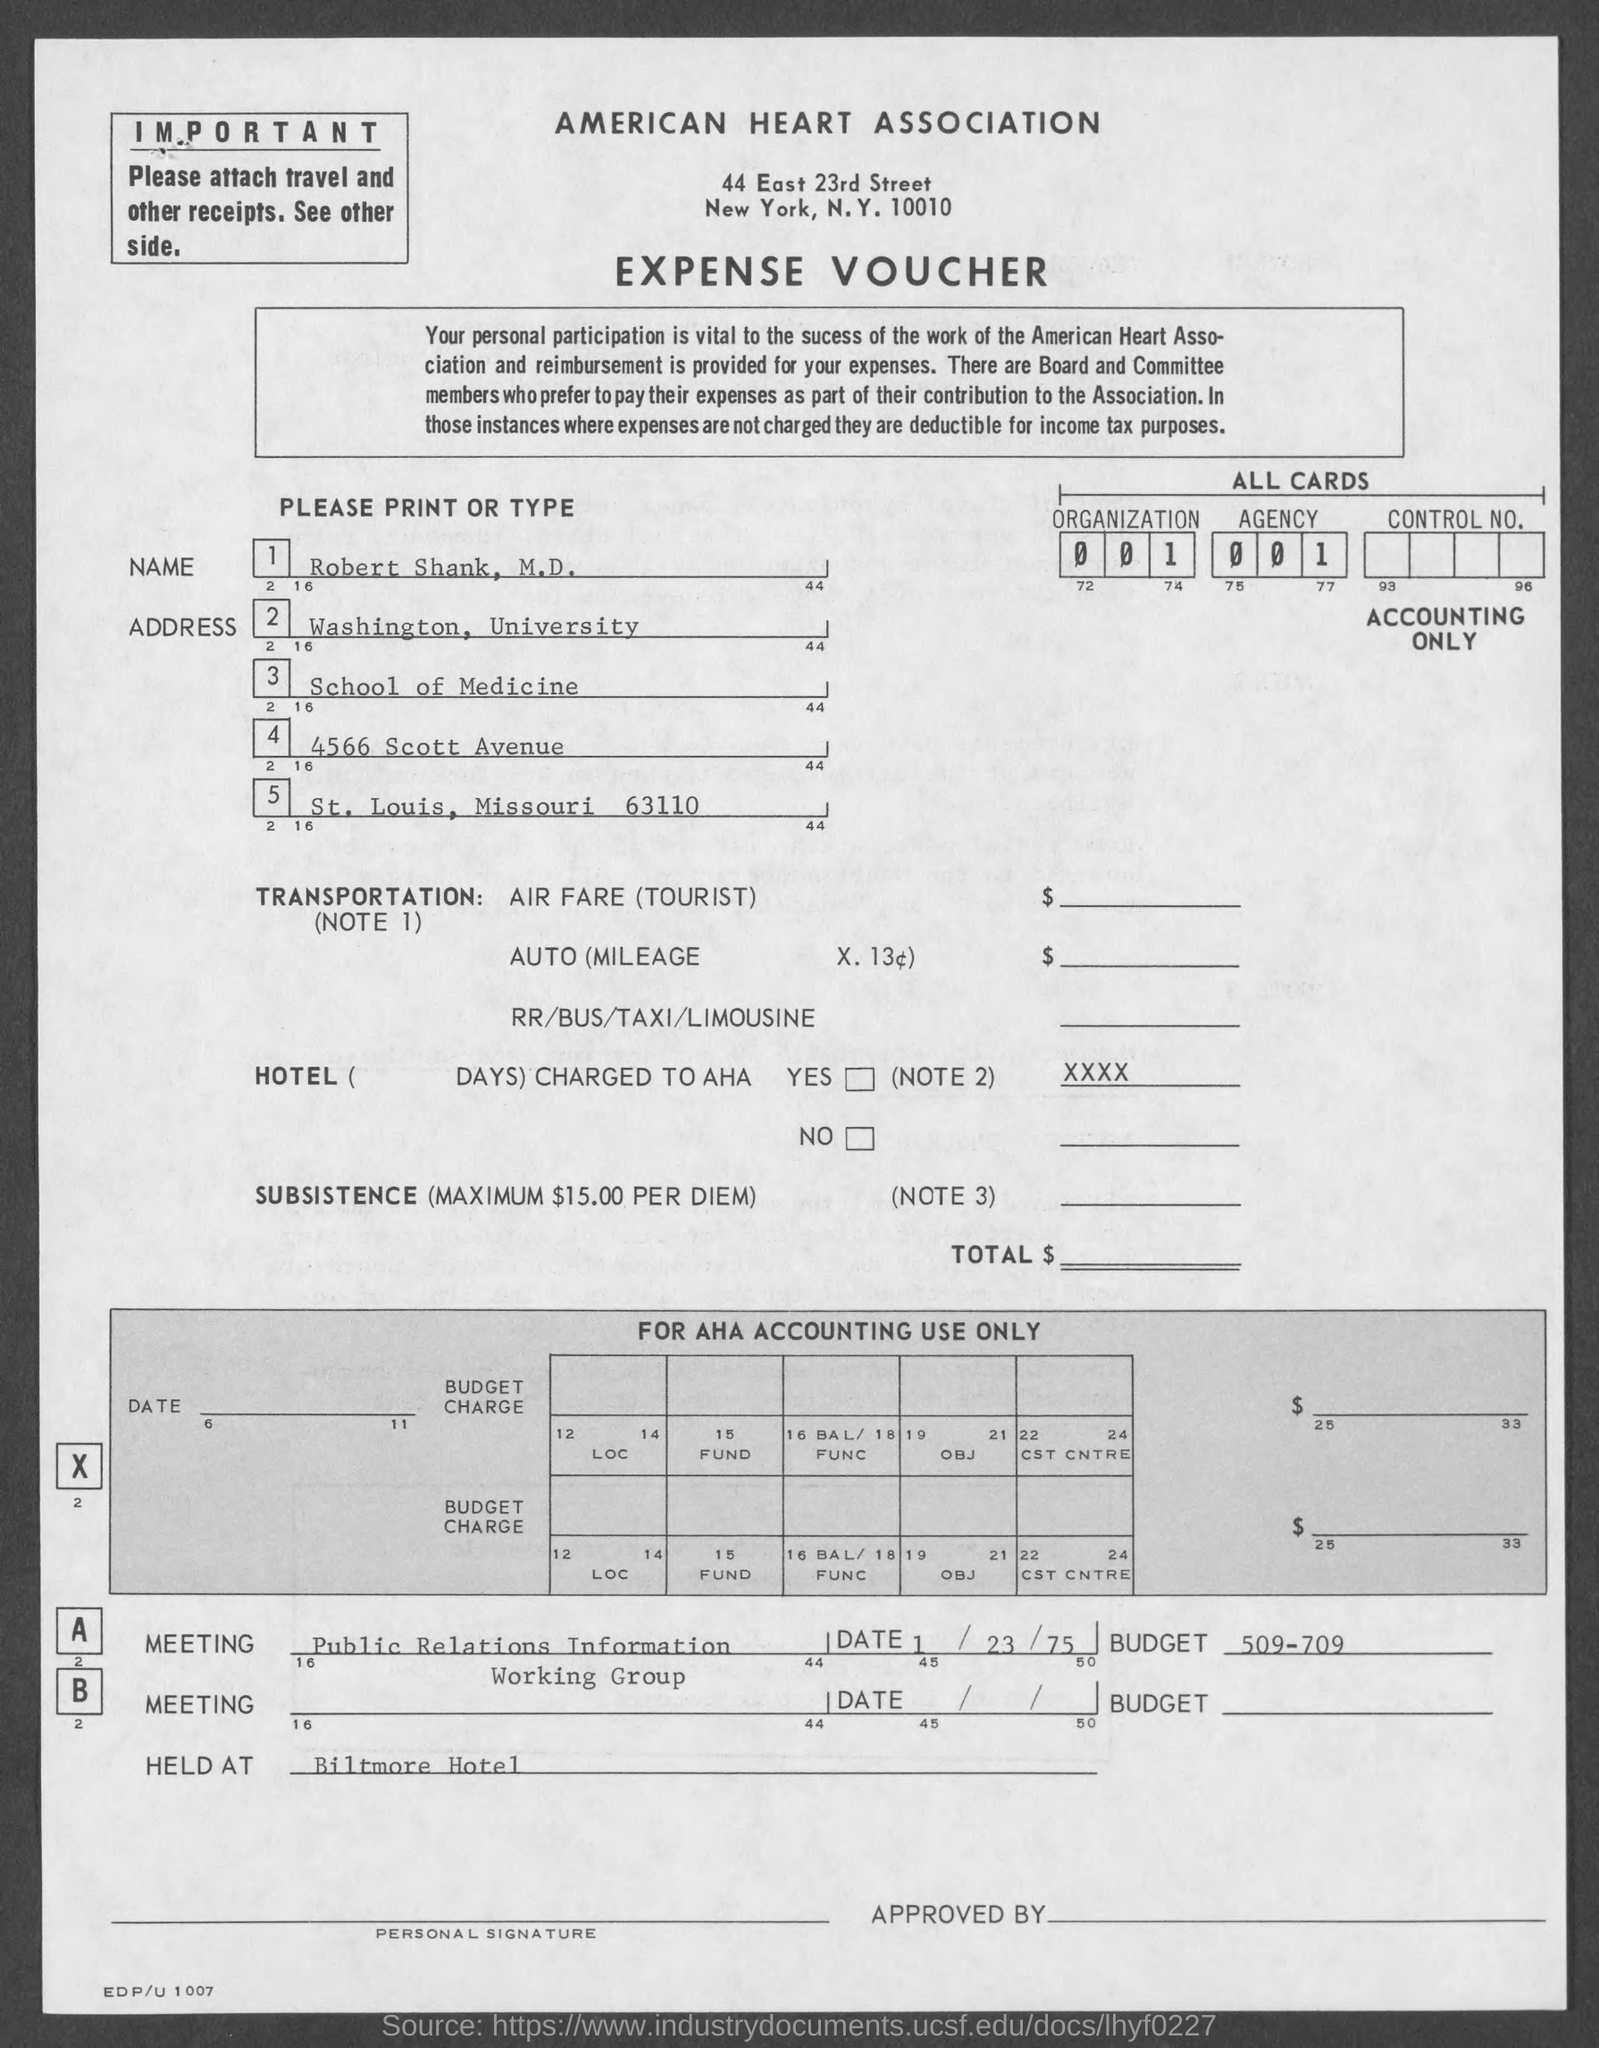Can you describe what type of document is shown in the image? The image displays an expense voucher from the American Heart Association. It details various expenditures and has sections for personal information, transportation costs, subsistence, and special instructions for accounting use, including a budget for specific meetings.  What date was assigned to Meeting A? Meeting A, the Public Relations Information Working Group, has the date '23/75' listed next to it, which seems to be an incorrect or incomplete date format. 